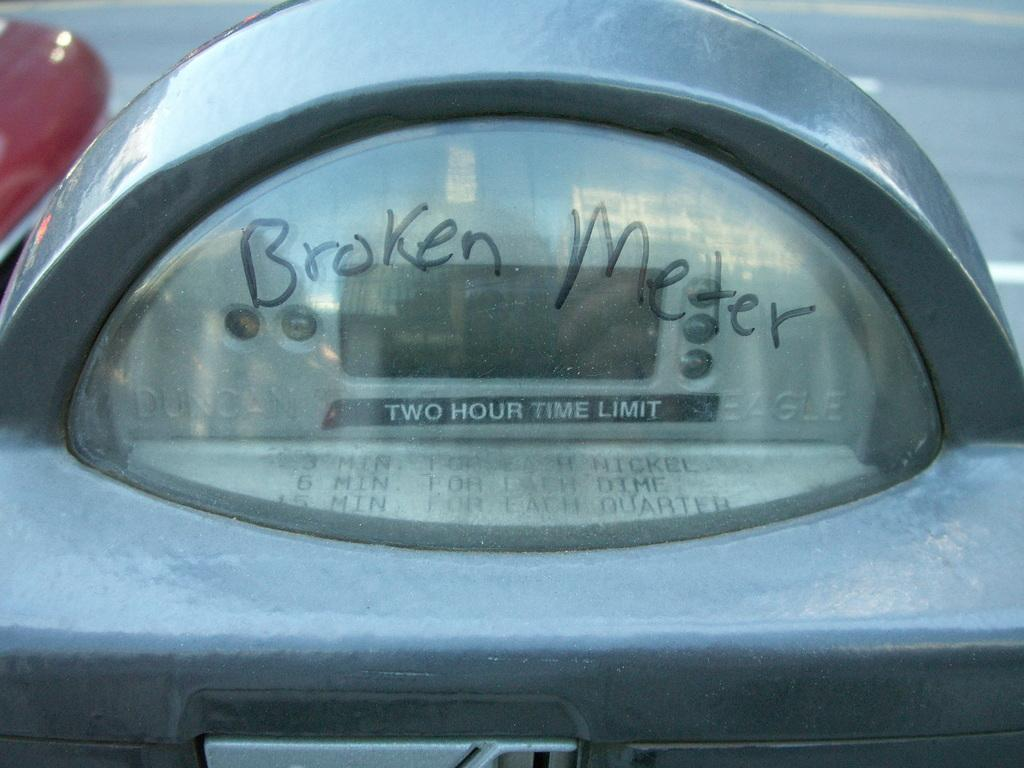Provide a one-sentence caption for the provided image. A meter on the side of the road reads Borken Meter. 